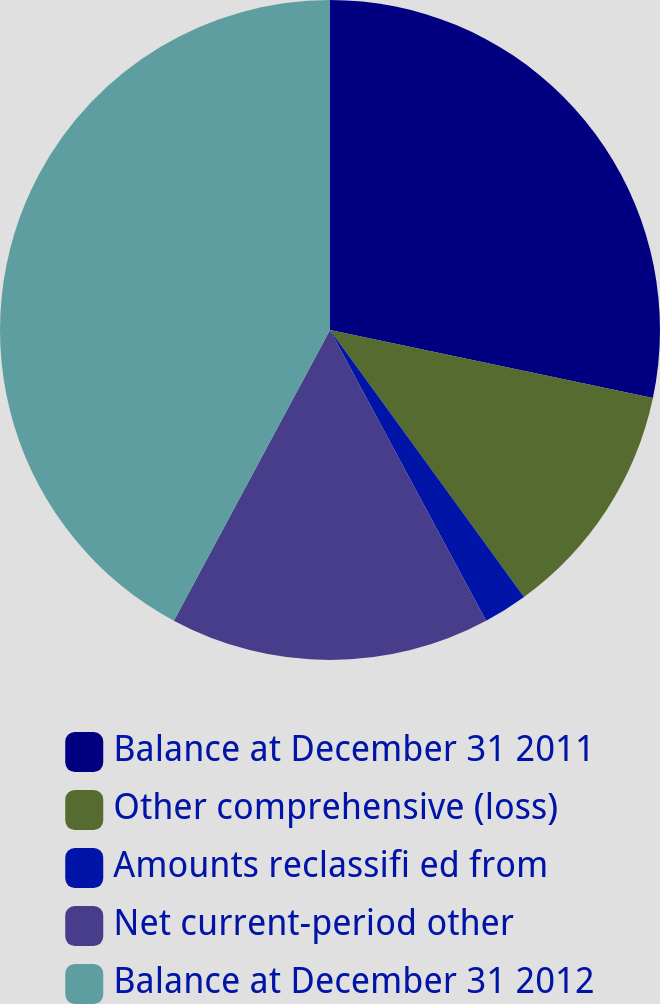Convert chart. <chart><loc_0><loc_0><loc_500><loc_500><pie_chart><fcel>Balance at December 31 2011<fcel>Other comprehensive (loss)<fcel>Amounts reclassifi ed from<fcel>Net current-period other<fcel>Balance at December 31 2012<nl><fcel>28.31%<fcel>11.69%<fcel>2.16%<fcel>15.69%<fcel>42.16%<nl></chart> 